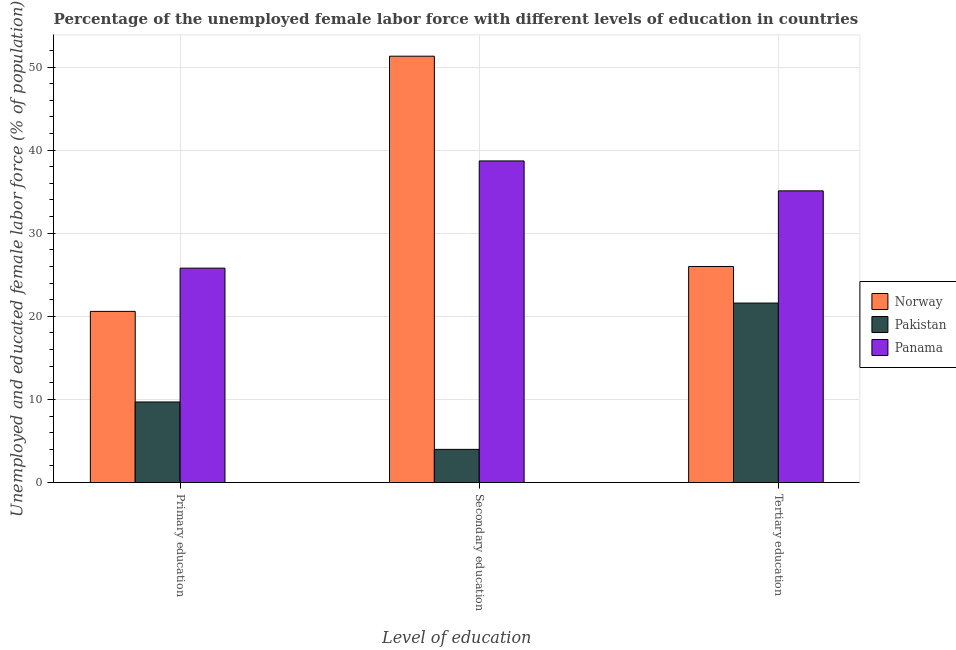How many different coloured bars are there?
Provide a short and direct response. 3. Are the number of bars per tick equal to the number of legend labels?
Your answer should be compact. Yes. How many bars are there on the 1st tick from the left?
Your answer should be very brief. 3. How many bars are there on the 3rd tick from the right?
Your answer should be compact. 3. What is the label of the 1st group of bars from the left?
Provide a short and direct response. Primary education. What is the percentage of female labor force who received tertiary education in Panama?
Ensure brevity in your answer.  35.1. Across all countries, what is the maximum percentage of female labor force who received secondary education?
Make the answer very short. 51.3. In which country was the percentage of female labor force who received primary education maximum?
Give a very brief answer. Panama. In which country was the percentage of female labor force who received primary education minimum?
Ensure brevity in your answer.  Pakistan. What is the total percentage of female labor force who received tertiary education in the graph?
Provide a short and direct response. 82.7. What is the difference between the percentage of female labor force who received tertiary education in Pakistan and that in Panama?
Provide a succinct answer. -13.5. What is the average percentage of female labor force who received tertiary education per country?
Keep it short and to the point. 27.57. What is the difference between the percentage of female labor force who received tertiary education and percentage of female labor force who received primary education in Norway?
Keep it short and to the point. 5.4. In how many countries, is the percentage of female labor force who received primary education greater than 20 %?
Your response must be concise. 2. What is the ratio of the percentage of female labor force who received secondary education in Norway to that in Pakistan?
Your answer should be very brief. 12.82. What is the difference between the highest and the second highest percentage of female labor force who received tertiary education?
Offer a very short reply. 9.1. What is the difference between the highest and the lowest percentage of female labor force who received primary education?
Provide a succinct answer. 16.1. In how many countries, is the percentage of female labor force who received secondary education greater than the average percentage of female labor force who received secondary education taken over all countries?
Give a very brief answer. 2. What does the 1st bar from the left in Secondary education represents?
Make the answer very short. Norway. What does the 1st bar from the right in Primary education represents?
Your response must be concise. Panama. How many bars are there?
Give a very brief answer. 9. Are all the bars in the graph horizontal?
Make the answer very short. No. How many countries are there in the graph?
Keep it short and to the point. 3. Are the values on the major ticks of Y-axis written in scientific E-notation?
Offer a terse response. No. Does the graph contain any zero values?
Keep it short and to the point. No. How are the legend labels stacked?
Your response must be concise. Vertical. What is the title of the graph?
Your response must be concise. Percentage of the unemployed female labor force with different levels of education in countries. Does "Solomon Islands" appear as one of the legend labels in the graph?
Provide a succinct answer. No. What is the label or title of the X-axis?
Offer a terse response. Level of education. What is the label or title of the Y-axis?
Offer a very short reply. Unemployed and educated female labor force (% of population). What is the Unemployed and educated female labor force (% of population) in Norway in Primary education?
Give a very brief answer. 20.6. What is the Unemployed and educated female labor force (% of population) in Pakistan in Primary education?
Your answer should be very brief. 9.7. What is the Unemployed and educated female labor force (% of population) of Panama in Primary education?
Provide a short and direct response. 25.8. What is the Unemployed and educated female labor force (% of population) of Norway in Secondary education?
Your answer should be compact. 51.3. What is the Unemployed and educated female labor force (% of population) in Pakistan in Secondary education?
Offer a terse response. 4. What is the Unemployed and educated female labor force (% of population) of Panama in Secondary education?
Give a very brief answer. 38.7. What is the Unemployed and educated female labor force (% of population) in Norway in Tertiary education?
Offer a very short reply. 26. What is the Unemployed and educated female labor force (% of population) of Pakistan in Tertiary education?
Provide a succinct answer. 21.6. What is the Unemployed and educated female labor force (% of population) in Panama in Tertiary education?
Your response must be concise. 35.1. Across all Level of education, what is the maximum Unemployed and educated female labor force (% of population) in Norway?
Provide a short and direct response. 51.3. Across all Level of education, what is the maximum Unemployed and educated female labor force (% of population) of Pakistan?
Your answer should be compact. 21.6. Across all Level of education, what is the maximum Unemployed and educated female labor force (% of population) in Panama?
Offer a terse response. 38.7. Across all Level of education, what is the minimum Unemployed and educated female labor force (% of population) in Norway?
Make the answer very short. 20.6. Across all Level of education, what is the minimum Unemployed and educated female labor force (% of population) of Panama?
Your answer should be compact. 25.8. What is the total Unemployed and educated female labor force (% of population) of Norway in the graph?
Your answer should be very brief. 97.9. What is the total Unemployed and educated female labor force (% of population) of Pakistan in the graph?
Make the answer very short. 35.3. What is the total Unemployed and educated female labor force (% of population) of Panama in the graph?
Make the answer very short. 99.6. What is the difference between the Unemployed and educated female labor force (% of population) in Norway in Primary education and that in Secondary education?
Your response must be concise. -30.7. What is the difference between the Unemployed and educated female labor force (% of population) of Norway in Primary education and that in Tertiary education?
Your answer should be very brief. -5.4. What is the difference between the Unemployed and educated female labor force (% of population) in Panama in Primary education and that in Tertiary education?
Keep it short and to the point. -9.3. What is the difference between the Unemployed and educated female labor force (% of population) in Norway in Secondary education and that in Tertiary education?
Keep it short and to the point. 25.3. What is the difference between the Unemployed and educated female labor force (% of population) in Pakistan in Secondary education and that in Tertiary education?
Your answer should be very brief. -17.6. What is the difference between the Unemployed and educated female labor force (% of population) in Panama in Secondary education and that in Tertiary education?
Provide a short and direct response. 3.6. What is the difference between the Unemployed and educated female labor force (% of population) in Norway in Primary education and the Unemployed and educated female labor force (% of population) in Panama in Secondary education?
Offer a terse response. -18.1. What is the difference between the Unemployed and educated female labor force (% of population) of Pakistan in Primary education and the Unemployed and educated female labor force (% of population) of Panama in Secondary education?
Give a very brief answer. -29. What is the difference between the Unemployed and educated female labor force (% of population) in Norway in Primary education and the Unemployed and educated female labor force (% of population) in Panama in Tertiary education?
Provide a short and direct response. -14.5. What is the difference between the Unemployed and educated female labor force (% of population) of Pakistan in Primary education and the Unemployed and educated female labor force (% of population) of Panama in Tertiary education?
Offer a very short reply. -25.4. What is the difference between the Unemployed and educated female labor force (% of population) in Norway in Secondary education and the Unemployed and educated female labor force (% of population) in Pakistan in Tertiary education?
Your answer should be compact. 29.7. What is the difference between the Unemployed and educated female labor force (% of population) in Norway in Secondary education and the Unemployed and educated female labor force (% of population) in Panama in Tertiary education?
Give a very brief answer. 16.2. What is the difference between the Unemployed and educated female labor force (% of population) of Pakistan in Secondary education and the Unemployed and educated female labor force (% of population) of Panama in Tertiary education?
Provide a succinct answer. -31.1. What is the average Unemployed and educated female labor force (% of population) in Norway per Level of education?
Offer a very short reply. 32.63. What is the average Unemployed and educated female labor force (% of population) of Pakistan per Level of education?
Your answer should be very brief. 11.77. What is the average Unemployed and educated female labor force (% of population) in Panama per Level of education?
Offer a terse response. 33.2. What is the difference between the Unemployed and educated female labor force (% of population) in Norway and Unemployed and educated female labor force (% of population) in Pakistan in Primary education?
Your response must be concise. 10.9. What is the difference between the Unemployed and educated female labor force (% of population) in Norway and Unemployed and educated female labor force (% of population) in Panama in Primary education?
Provide a succinct answer. -5.2. What is the difference between the Unemployed and educated female labor force (% of population) of Pakistan and Unemployed and educated female labor force (% of population) of Panama in Primary education?
Offer a terse response. -16.1. What is the difference between the Unemployed and educated female labor force (% of population) of Norway and Unemployed and educated female labor force (% of population) of Pakistan in Secondary education?
Make the answer very short. 47.3. What is the difference between the Unemployed and educated female labor force (% of population) in Norway and Unemployed and educated female labor force (% of population) in Panama in Secondary education?
Ensure brevity in your answer.  12.6. What is the difference between the Unemployed and educated female labor force (% of population) in Pakistan and Unemployed and educated female labor force (% of population) in Panama in Secondary education?
Offer a terse response. -34.7. What is the ratio of the Unemployed and educated female labor force (% of population) in Norway in Primary education to that in Secondary education?
Give a very brief answer. 0.4. What is the ratio of the Unemployed and educated female labor force (% of population) of Pakistan in Primary education to that in Secondary education?
Provide a short and direct response. 2.42. What is the ratio of the Unemployed and educated female labor force (% of population) in Panama in Primary education to that in Secondary education?
Give a very brief answer. 0.67. What is the ratio of the Unemployed and educated female labor force (% of population) in Norway in Primary education to that in Tertiary education?
Give a very brief answer. 0.79. What is the ratio of the Unemployed and educated female labor force (% of population) of Pakistan in Primary education to that in Tertiary education?
Your answer should be very brief. 0.45. What is the ratio of the Unemployed and educated female labor force (% of population) in Panama in Primary education to that in Tertiary education?
Your answer should be very brief. 0.73. What is the ratio of the Unemployed and educated female labor force (% of population) in Norway in Secondary education to that in Tertiary education?
Give a very brief answer. 1.97. What is the ratio of the Unemployed and educated female labor force (% of population) of Pakistan in Secondary education to that in Tertiary education?
Offer a terse response. 0.19. What is the ratio of the Unemployed and educated female labor force (% of population) of Panama in Secondary education to that in Tertiary education?
Your answer should be very brief. 1.1. What is the difference between the highest and the second highest Unemployed and educated female labor force (% of population) in Norway?
Your answer should be compact. 25.3. What is the difference between the highest and the lowest Unemployed and educated female labor force (% of population) in Norway?
Your response must be concise. 30.7. 